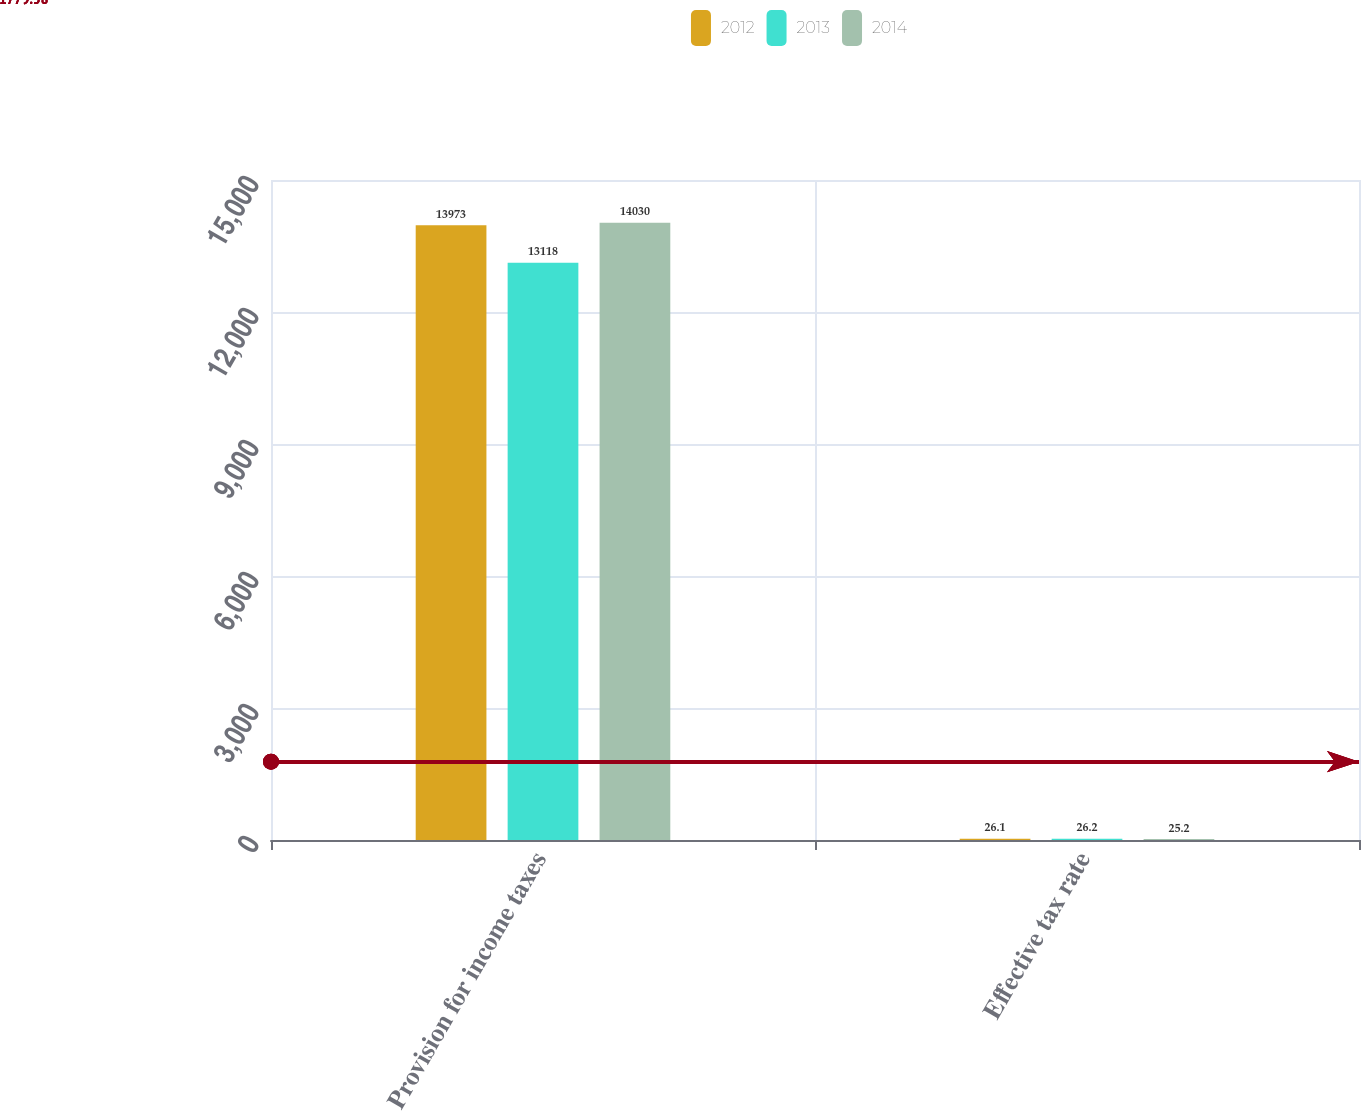Convert chart to OTSL. <chart><loc_0><loc_0><loc_500><loc_500><stacked_bar_chart><ecel><fcel>Provision for income taxes<fcel>Effective tax rate<nl><fcel>2012<fcel>13973<fcel>26.1<nl><fcel>2013<fcel>13118<fcel>26.2<nl><fcel>2014<fcel>14030<fcel>25.2<nl></chart> 